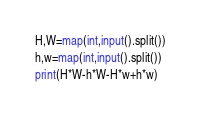Convert code to text. <code><loc_0><loc_0><loc_500><loc_500><_Python_>H,W=map(int,input().split())
h,w=map(int,input().split())
print(H*W-h*W-H*w+h*w)
</code> 